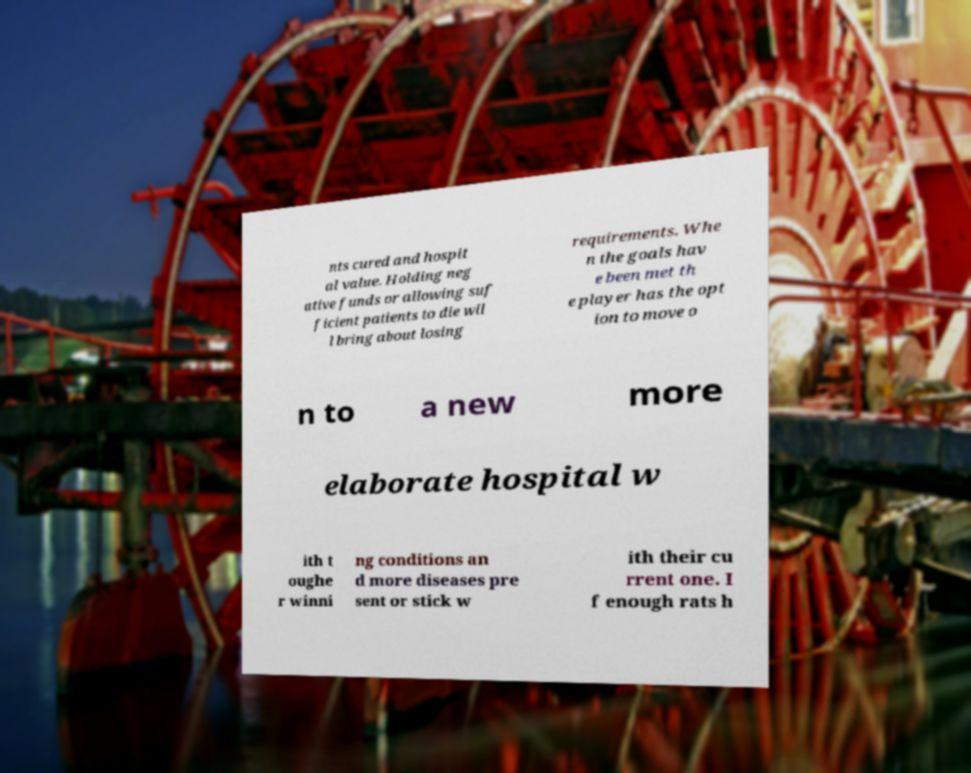For documentation purposes, I need the text within this image transcribed. Could you provide that? nts cured and hospit al value. Holding neg ative funds or allowing suf ficient patients to die wil l bring about losing requirements. Whe n the goals hav e been met th e player has the opt ion to move o n to a new more elaborate hospital w ith t oughe r winni ng conditions an d more diseases pre sent or stick w ith their cu rrent one. I f enough rats h 